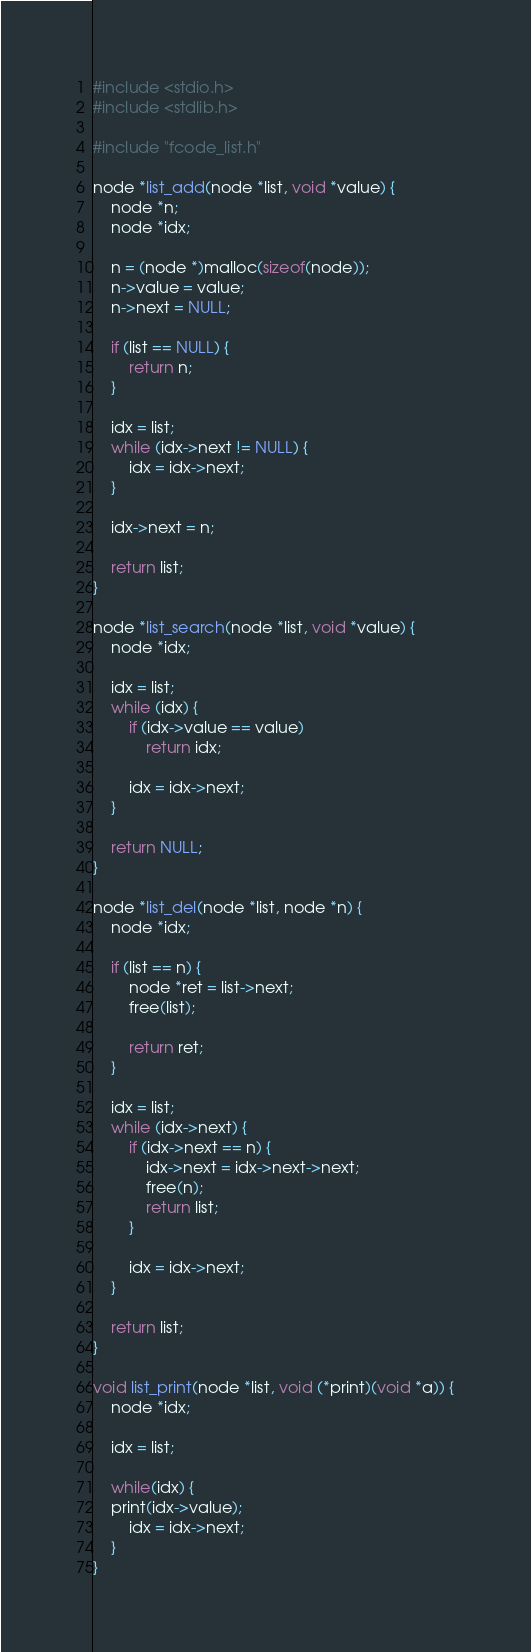Convert code to text. <code><loc_0><loc_0><loc_500><loc_500><_C_>#include <stdio.h>
#include <stdlib.h>

#include "fcode_list.h"

node *list_add(node *list, void *value) {
    node *n;
    node *idx;

    n = (node *)malloc(sizeof(node));
    n->value = value;
    n->next = NULL;

    if (list == NULL) {
        return n; 
    }

    idx = list;
    while (idx->next != NULL) {
        idx = idx->next;
    }

    idx->next = n;

    return list;
}

node *list_search(node *list, void *value) {
    node *idx;

    idx = list;
    while (idx) {
        if (idx->value == value)
            return idx;

        idx = idx->next;
    }

    return NULL;
}

node *list_del(node *list, node *n) {
    node *idx;

    if (list == n) {
        node *ret = list->next;
        free(list);

        return ret;
    }

    idx = list;
    while (idx->next) {
        if (idx->next == n) {
            idx->next = idx->next->next;
            free(n);
            return list;
        }

        idx = idx->next;
    }

    return list;
}

void list_print(node *list, void (*print)(void *a)) {
    node *idx;

    idx = list;

    while(idx) {
	print(idx->value);
        idx = idx->next;
    }
}

</code> 